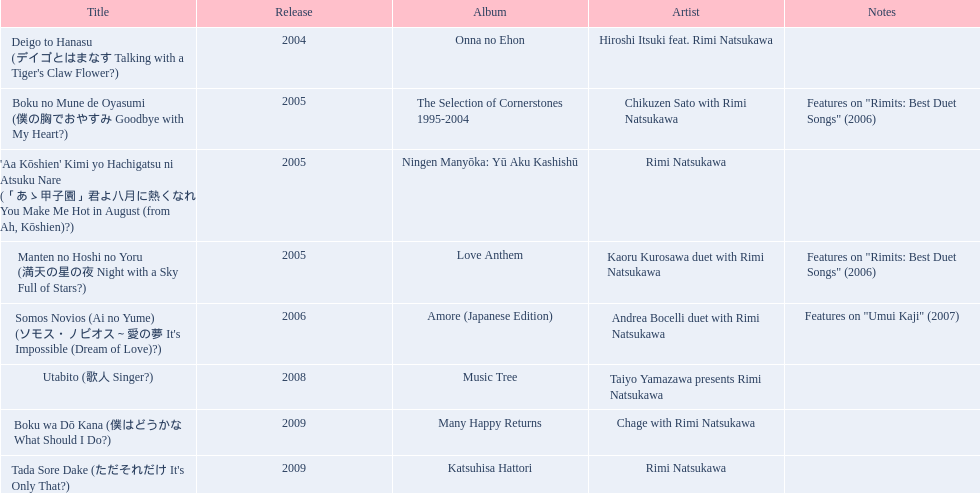What are the names of each album by rimi natsukawa? Onna no Ehon, The Selection of Cornerstones 1995-2004, Ningen Manyōka: Yū Aku Kashishū, Love Anthem, Amore (Japanese Edition), Music Tree, Many Happy Returns, Katsuhisa Hattori. And when were the albums released? 2004, 2005, 2005, 2005, 2006, 2008, 2009, 2009. Was onna no ehon or music tree released most recently? Music Tree. 